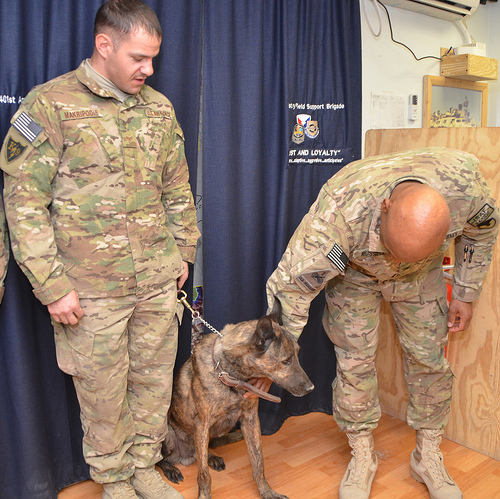<image>
Is there a photo to the right of the curtain? Yes. From this viewpoint, the photo is positioned to the right side relative to the curtain. Where is the curtain in relation to the dog? Is it behind the dog? Yes. From this viewpoint, the curtain is positioned behind the dog, with the dog partially or fully occluding the curtain. Is there a man in front of the dog? No. The man is not in front of the dog. The spatial positioning shows a different relationship between these objects. 